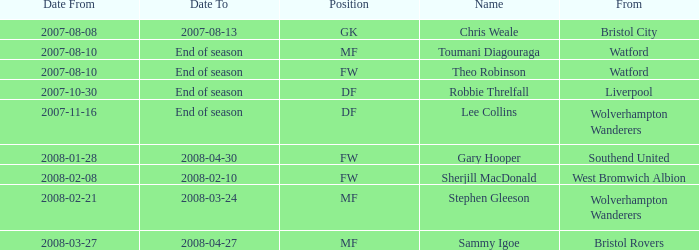How was the 'date from' represented for 2007-08-08? Bristol City. 